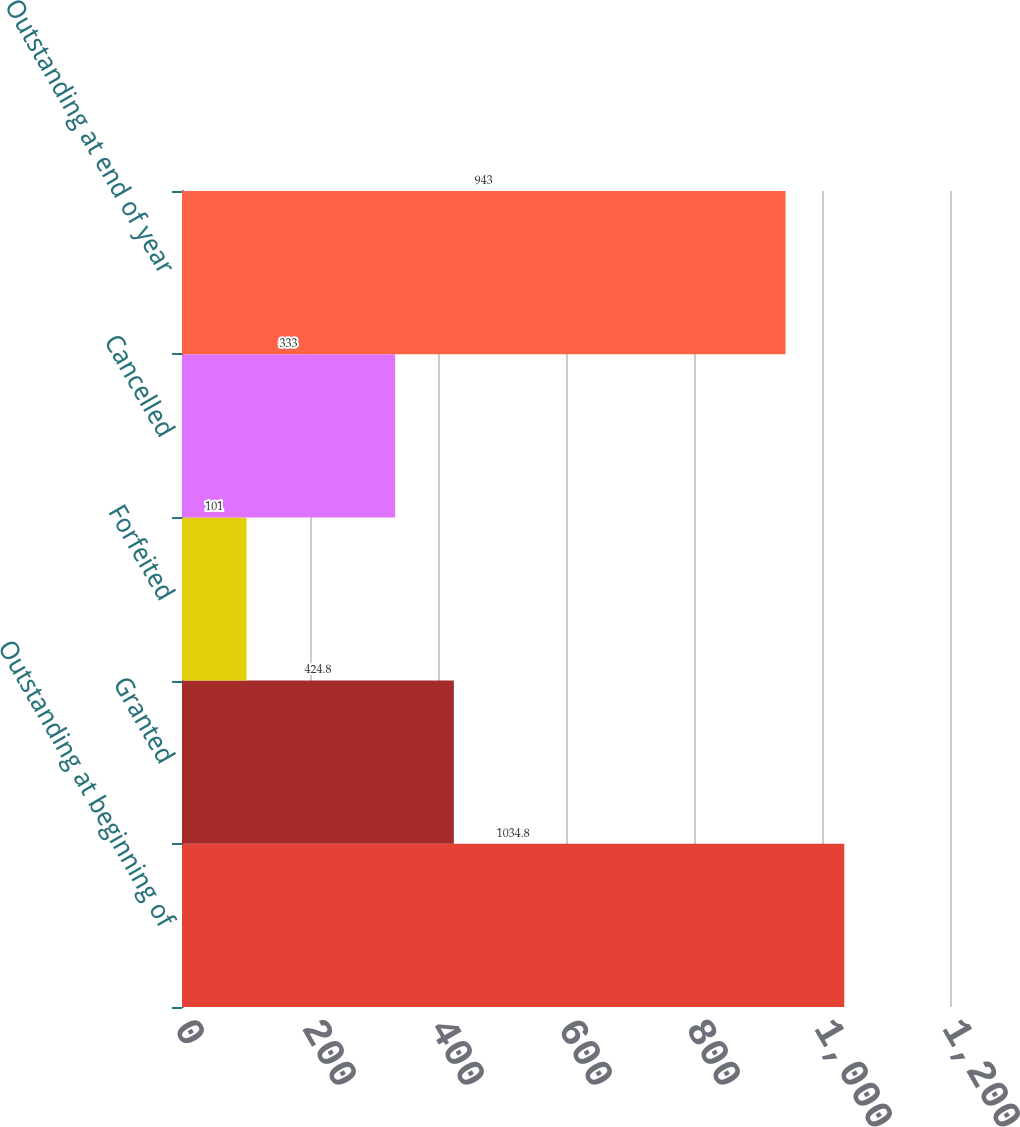Convert chart. <chart><loc_0><loc_0><loc_500><loc_500><bar_chart><fcel>Outstanding at beginning of<fcel>Granted<fcel>Forfeited<fcel>Cancelled<fcel>Outstanding at end of year<nl><fcel>1034.8<fcel>424.8<fcel>101<fcel>333<fcel>943<nl></chart> 